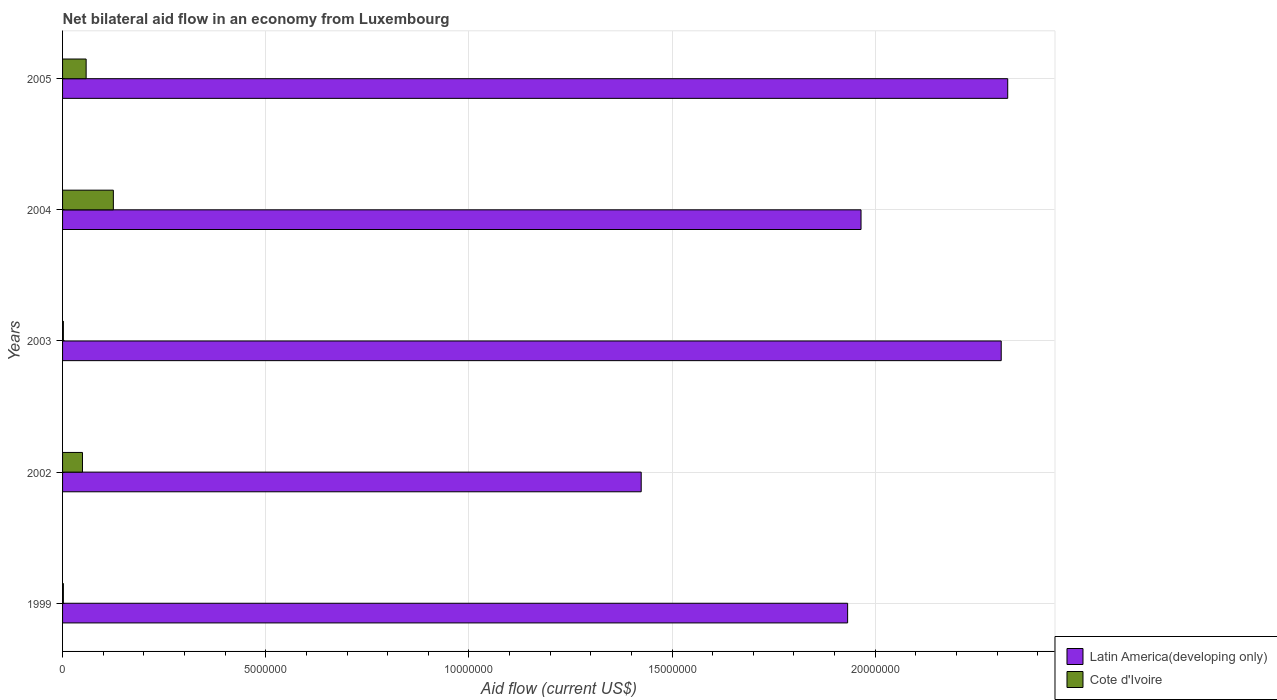Are the number of bars per tick equal to the number of legend labels?
Provide a short and direct response. Yes. How many bars are there on the 3rd tick from the bottom?
Provide a succinct answer. 2. What is the label of the 4th group of bars from the top?
Make the answer very short. 2002. Across all years, what is the maximum net bilateral aid flow in Cote d'Ivoire?
Keep it short and to the point. 1.25e+06. Across all years, what is the minimum net bilateral aid flow in Latin America(developing only)?
Provide a succinct answer. 1.42e+07. In which year was the net bilateral aid flow in Latin America(developing only) maximum?
Provide a short and direct response. 2005. What is the total net bilateral aid flow in Cote d'Ivoire in the graph?
Provide a short and direct response. 2.36e+06. What is the difference between the net bilateral aid flow in Cote d'Ivoire in 1999 and that in 2003?
Offer a terse response. 0. What is the difference between the net bilateral aid flow in Latin America(developing only) in 1999 and the net bilateral aid flow in Cote d'Ivoire in 2003?
Provide a short and direct response. 1.93e+07. What is the average net bilateral aid flow in Latin America(developing only) per year?
Provide a short and direct response. 1.99e+07. In the year 2005, what is the difference between the net bilateral aid flow in Cote d'Ivoire and net bilateral aid flow in Latin America(developing only)?
Make the answer very short. -2.27e+07. In how many years, is the net bilateral aid flow in Cote d'Ivoire greater than 5000000 US$?
Provide a short and direct response. 0. What is the ratio of the net bilateral aid flow in Latin America(developing only) in 2002 to that in 2004?
Your response must be concise. 0.72. Is the net bilateral aid flow in Cote d'Ivoire in 2002 less than that in 2004?
Give a very brief answer. Yes. Is the difference between the net bilateral aid flow in Cote d'Ivoire in 1999 and 2004 greater than the difference between the net bilateral aid flow in Latin America(developing only) in 1999 and 2004?
Keep it short and to the point. No. What is the difference between the highest and the lowest net bilateral aid flow in Latin America(developing only)?
Provide a succinct answer. 9.02e+06. In how many years, is the net bilateral aid flow in Cote d'Ivoire greater than the average net bilateral aid flow in Cote d'Ivoire taken over all years?
Give a very brief answer. 3. What does the 2nd bar from the top in 2002 represents?
Make the answer very short. Latin America(developing only). What does the 2nd bar from the bottom in 2002 represents?
Your answer should be very brief. Cote d'Ivoire. Are the values on the major ticks of X-axis written in scientific E-notation?
Give a very brief answer. No. How are the legend labels stacked?
Ensure brevity in your answer.  Vertical. What is the title of the graph?
Offer a terse response. Net bilateral aid flow in an economy from Luxembourg. Does "United States" appear as one of the legend labels in the graph?
Offer a terse response. No. What is the label or title of the X-axis?
Keep it short and to the point. Aid flow (current US$). What is the Aid flow (current US$) in Latin America(developing only) in 1999?
Offer a very short reply. 1.93e+07. What is the Aid flow (current US$) of Latin America(developing only) in 2002?
Provide a succinct answer. 1.42e+07. What is the Aid flow (current US$) of Latin America(developing only) in 2003?
Provide a short and direct response. 2.31e+07. What is the Aid flow (current US$) of Latin America(developing only) in 2004?
Ensure brevity in your answer.  1.96e+07. What is the Aid flow (current US$) of Cote d'Ivoire in 2004?
Offer a very short reply. 1.25e+06. What is the Aid flow (current US$) of Latin America(developing only) in 2005?
Give a very brief answer. 2.33e+07. What is the Aid flow (current US$) of Cote d'Ivoire in 2005?
Your answer should be very brief. 5.80e+05. Across all years, what is the maximum Aid flow (current US$) of Latin America(developing only)?
Give a very brief answer. 2.33e+07. Across all years, what is the maximum Aid flow (current US$) in Cote d'Ivoire?
Your answer should be very brief. 1.25e+06. Across all years, what is the minimum Aid flow (current US$) in Latin America(developing only)?
Provide a succinct answer. 1.42e+07. What is the total Aid flow (current US$) in Latin America(developing only) in the graph?
Make the answer very short. 9.96e+07. What is the total Aid flow (current US$) in Cote d'Ivoire in the graph?
Make the answer very short. 2.36e+06. What is the difference between the Aid flow (current US$) of Latin America(developing only) in 1999 and that in 2002?
Give a very brief answer. 5.08e+06. What is the difference between the Aid flow (current US$) in Cote d'Ivoire in 1999 and that in 2002?
Offer a terse response. -4.70e+05. What is the difference between the Aid flow (current US$) of Latin America(developing only) in 1999 and that in 2003?
Offer a terse response. -3.78e+06. What is the difference between the Aid flow (current US$) of Cote d'Ivoire in 1999 and that in 2003?
Provide a succinct answer. 0. What is the difference between the Aid flow (current US$) of Latin America(developing only) in 1999 and that in 2004?
Your response must be concise. -3.30e+05. What is the difference between the Aid flow (current US$) of Cote d'Ivoire in 1999 and that in 2004?
Provide a succinct answer. -1.23e+06. What is the difference between the Aid flow (current US$) of Latin America(developing only) in 1999 and that in 2005?
Offer a very short reply. -3.94e+06. What is the difference between the Aid flow (current US$) in Cote d'Ivoire in 1999 and that in 2005?
Provide a succinct answer. -5.60e+05. What is the difference between the Aid flow (current US$) in Latin America(developing only) in 2002 and that in 2003?
Provide a succinct answer. -8.86e+06. What is the difference between the Aid flow (current US$) in Cote d'Ivoire in 2002 and that in 2003?
Give a very brief answer. 4.70e+05. What is the difference between the Aid flow (current US$) in Latin America(developing only) in 2002 and that in 2004?
Make the answer very short. -5.41e+06. What is the difference between the Aid flow (current US$) in Cote d'Ivoire in 2002 and that in 2004?
Offer a very short reply. -7.60e+05. What is the difference between the Aid flow (current US$) of Latin America(developing only) in 2002 and that in 2005?
Your answer should be very brief. -9.02e+06. What is the difference between the Aid flow (current US$) in Cote d'Ivoire in 2002 and that in 2005?
Ensure brevity in your answer.  -9.00e+04. What is the difference between the Aid flow (current US$) of Latin America(developing only) in 2003 and that in 2004?
Your answer should be very brief. 3.45e+06. What is the difference between the Aid flow (current US$) of Cote d'Ivoire in 2003 and that in 2004?
Give a very brief answer. -1.23e+06. What is the difference between the Aid flow (current US$) in Cote d'Ivoire in 2003 and that in 2005?
Your answer should be compact. -5.60e+05. What is the difference between the Aid flow (current US$) of Latin America(developing only) in 2004 and that in 2005?
Make the answer very short. -3.61e+06. What is the difference between the Aid flow (current US$) of Cote d'Ivoire in 2004 and that in 2005?
Your answer should be very brief. 6.70e+05. What is the difference between the Aid flow (current US$) of Latin America(developing only) in 1999 and the Aid flow (current US$) of Cote d'Ivoire in 2002?
Make the answer very short. 1.88e+07. What is the difference between the Aid flow (current US$) of Latin America(developing only) in 1999 and the Aid flow (current US$) of Cote d'Ivoire in 2003?
Ensure brevity in your answer.  1.93e+07. What is the difference between the Aid flow (current US$) of Latin America(developing only) in 1999 and the Aid flow (current US$) of Cote d'Ivoire in 2004?
Offer a very short reply. 1.81e+07. What is the difference between the Aid flow (current US$) in Latin America(developing only) in 1999 and the Aid flow (current US$) in Cote d'Ivoire in 2005?
Make the answer very short. 1.87e+07. What is the difference between the Aid flow (current US$) of Latin America(developing only) in 2002 and the Aid flow (current US$) of Cote d'Ivoire in 2003?
Offer a very short reply. 1.42e+07. What is the difference between the Aid flow (current US$) of Latin America(developing only) in 2002 and the Aid flow (current US$) of Cote d'Ivoire in 2004?
Make the answer very short. 1.30e+07. What is the difference between the Aid flow (current US$) in Latin America(developing only) in 2002 and the Aid flow (current US$) in Cote d'Ivoire in 2005?
Keep it short and to the point. 1.37e+07. What is the difference between the Aid flow (current US$) of Latin America(developing only) in 2003 and the Aid flow (current US$) of Cote d'Ivoire in 2004?
Give a very brief answer. 2.18e+07. What is the difference between the Aid flow (current US$) in Latin America(developing only) in 2003 and the Aid flow (current US$) in Cote d'Ivoire in 2005?
Keep it short and to the point. 2.25e+07. What is the difference between the Aid flow (current US$) of Latin America(developing only) in 2004 and the Aid flow (current US$) of Cote d'Ivoire in 2005?
Offer a very short reply. 1.91e+07. What is the average Aid flow (current US$) in Latin America(developing only) per year?
Keep it short and to the point. 1.99e+07. What is the average Aid flow (current US$) in Cote d'Ivoire per year?
Give a very brief answer. 4.72e+05. In the year 1999, what is the difference between the Aid flow (current US$) in Latin America(developing only) and Aid flow (current US$) in Cote d'Ivoire?
Offer a very short reply. 1.93e+07. In the year 2002, what is the difference between the Aid flow (current US$) in Latin America(developing only) and Aid flow (current US$) in Cote d'Ivoire?
Your answer should be compact. 1.38e+07. In the year 2003, what is the difference between the Aid flow (current US$) in Latin America(developing only) and Aid flow (current US$) in Cote d'Ivoire?
Offer a very short reply. 2.31e+07. In the year 2004, what is the difference between the Aid flow (current US$) in Latin America(developing only) and Aid flow (current US$) in Cote d'Ivoire?
Provide a succinct answer. 1.84e+07. In the year 2005, what is the difference between the Aid flow (current US$) in Latin America(developing only) and Aid flow (current US$) in Cote d'Ivoire?
Give a very brief answer. 2.27e+07. What is the ratio of the Aid flow (current US$) of Latin America(developing only) in 1999 to that in 2002?
Your response must be concise. 1.36. What is the ratio of the Aid flow (current US$) in Cote d'Ivoire in 1999 to that in 2002?
Keep it short and to the point. 0.04. What is the ratio of the Aid flow (current US$) of Latin America(developing only) in 1999 to that in 2003?
Ensure brevity in your answer.  0.84. What is the ratio of the Aid flow (current US$) in Cote d'Ivoire in 1999 to that in 2003?
Your answer should be compact. 1. What is the ratio of the Aid flow (current US$) of Latin America(developing only) in 1999 to that in 2004?
Make the answer very short. 0.98. What is the ratio of the Aid flow (current US$) in Cote d'Ivoire in 1999 to that in 2004?
Make the answer very short. 0.02. What is the ratio of the Aid flow (current US$) in Latin America(developing only) in 1999 to that in 2005?
Your answer should be very brief. 0.83. What is the ratio of the Aid flow (current US$) in Cote d'Ivoire in 1999 to that in 2005?
Provide a succinct answer. 0.03. What is the ratio of the Aid flow (current US$) of Latin America(developing only) in 2002 to that in 2003?
Your answer should be very brief. 0.62. What is the ratio of the Aid flow (current US$) in Cote d'Ivoire in 2002 to that in 2003?
Your answer should be very brief. 24.5. What is the ratio of the Aid flow (current US$) in Latin America(developing only) in 2002 to that in 2004?
Your response must be concise. 0.72. What is the ratio of the Aid flow (current US$) of Cote d'Ivoire in 2002 to that in 2004?
Provide a short and direct response. 0.39. What is the ratio of the Aid flow (current US$) in Latin America(developing only) in 2002 to that in 2005?
Your answer should be compact. 0.61. What is the ratio of the Aid flow (current US$) in Cote d'Ivoire in 2002 to that in 2005?
Provide a succinct answer. 0.84. What is the ratio of the Aid flow (current US$) in Latin America(developing only) in 2003 to that in 2004?
Keep it short and to the point. 1.18. What is the ratio of the Aid flow (current US$) of Cote d'Ivoire in 2003 to that in 2004?
Keep it short and to the point. 0.02. What is the ratio of the Aid flow (current US$) of Cote d'Ivoire in 2003 to that in 2005?
Provide a succinct answer. 0.03. What is the ratio of the Aid flow (current US$) in Latin America(developing only) in 2004 to that in 2005?
Give a very brief answer. 0.84. What is the ratio of the Aid flow (current US$) in Cote d'Ivoire in 2004 to that in 2005?
Provide a short and direct response. 2.16. What is the difference between the highest and the second highest Aid flow (current US$) of Latin America(developing only)?
Give a very brief answer. 1.60e+05. What is the difference between the highest and the second highest Aid flow (current US$) in Cote d'Ivoire?
Offer a very short reply. 6.70e+05. What is the difference between the highest and the lowest Aid flow (current US$) of Latin America(developing only)?
Offer a terse response. 9.02e+06. What is the difference between the highest and the lowest Aid flow (current US$) of Cote d'Ivoire?
Provide a short and direct response. 1.23e+06. 